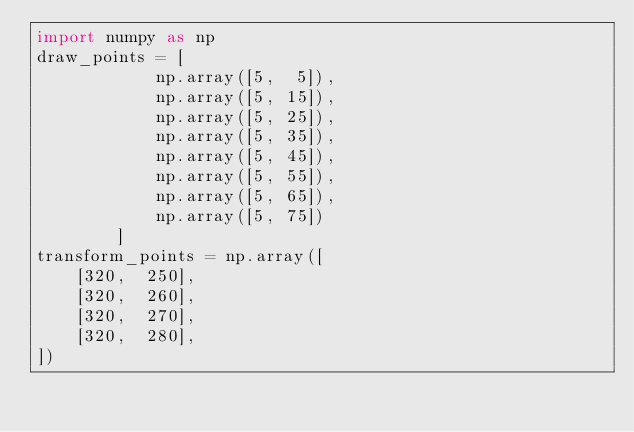<code> <loc_0><loc_0><loc_500><loc_500><_Python_>import numpy as np
draw_points = [
            np.array([5,  5]),
            np.array([5, 15]),
            np.array([5, 25]),
            np.array([5, 35]),
            np.array([5, 45]),
            np.array([5, 55]),
            np.array([5, 65]),
            np.array([5, 75])
        ]
transform_points = np.array([
    [320,  250],
    [320,  260],
    [320,  270],
    [320,  280],
])</code> 